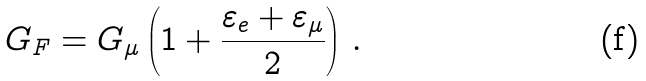<formula> <loc_0><loc_0><loc_500><loc_500>G _ { F } = G _ { \mu } \left ( 1 + \frac { \varepsilon _ { e } + \varepsilon _ { \mu } } { 2 } \right ) \, .</formula> 